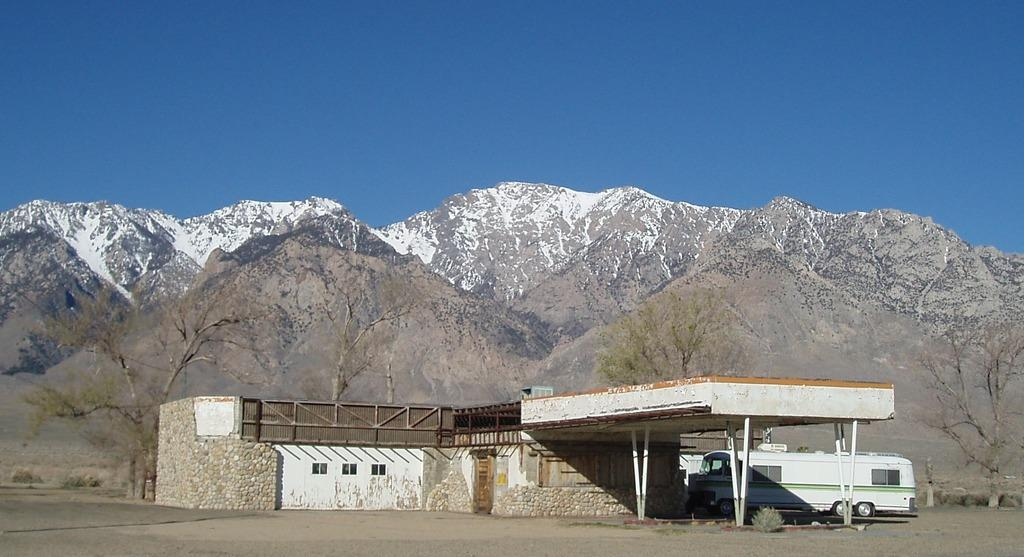What type of structure is in the image? There is a building in the image. Where is the building located? The building is on the ground. What else can be seen in the image besides the building? There is a bus and mountains visible in the image. What is the condition of the mountains in the image? The mountains have snow on them. What is visible at the top of the image? The sky is visible at the top of the image. Who is the creator of the camera used to take the image? There is no information about the camera used to take the image, nor any reference to a creator. 